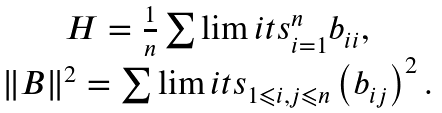Convert formula to latex. <formula><loc_0><loc_0><loc_500><loc_500>\begin{array} { c } H = \frac { 1 } { n } \sum \lim i t s _ { i = 1 } ^ { n } b _ { i i } , \\ \| B \| ^ { 2 } = \sum \lim i t s _ { 1 \leqslant i , j \leqslant n } \left ( b _ { i j } \right ) ^ { 2 } . \\ \end{array}</formula> 